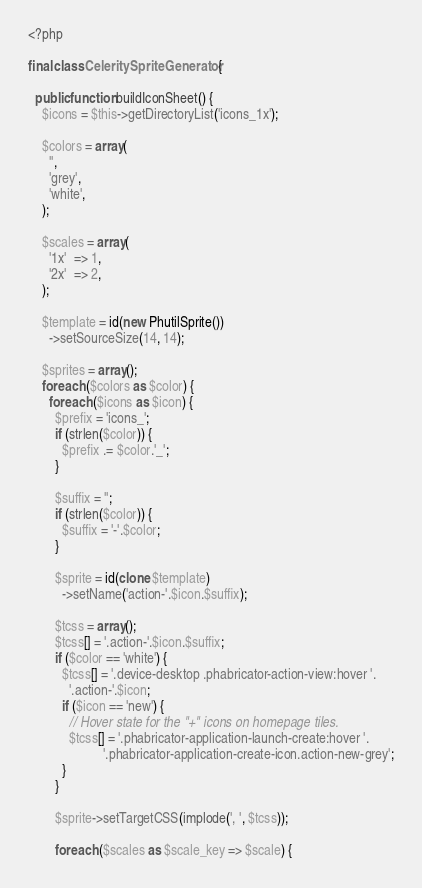Convert code to text. <code><loc_0><loc_0><loc_500><loc_500><_PHP_><?php

final class CeleritySpriteGenerator {

  public function buildIconSheet() {
    $icons = $this->getDirectoryList('icons_1x');

    $colors = array(
      '',
      'grey',
      'white',
    );

    $scales = array(
      '1x'  => 1,
      '2x'  => 2,
    );

    $template = id(new PhutilSprite())
      ->setSourceSize(14, 14);

    $sprites = array();
    foreach ($colors as $color) {
      foreach ($icons as $icon) {
        $prefix = 'icons_';
        if (strlen($color)) {
          $prefix .= $color.'_';
        }

        $suffix = '';
        if (strlen($color)) {
          $suffix = '-'.$color;
        }

        $sprite = id(clone $template)
          ->setName('action-'.$icon.$suffix);

        $tcss = array();
        $tcss[] = '.action-'.$icon.$suffix;
        if ($color == 'white') {
          $tcss[] = '.device-desktop .phabricator-action-view:hover '.
            '.action-'.$icon;
          if ($icon == 'new') {
            // Hover state for the "+" icons on homepage tiles.
            $tcss[] = '.phabricator-application-launch-create:hover '.
                      '.phabricator-application-create-icon.action-new-grey';
          }
        }

        $sprite->setTargetCSS(implode(', ', $tcss));

        foreach ($scales as $scale_key => $scale) {</code> 